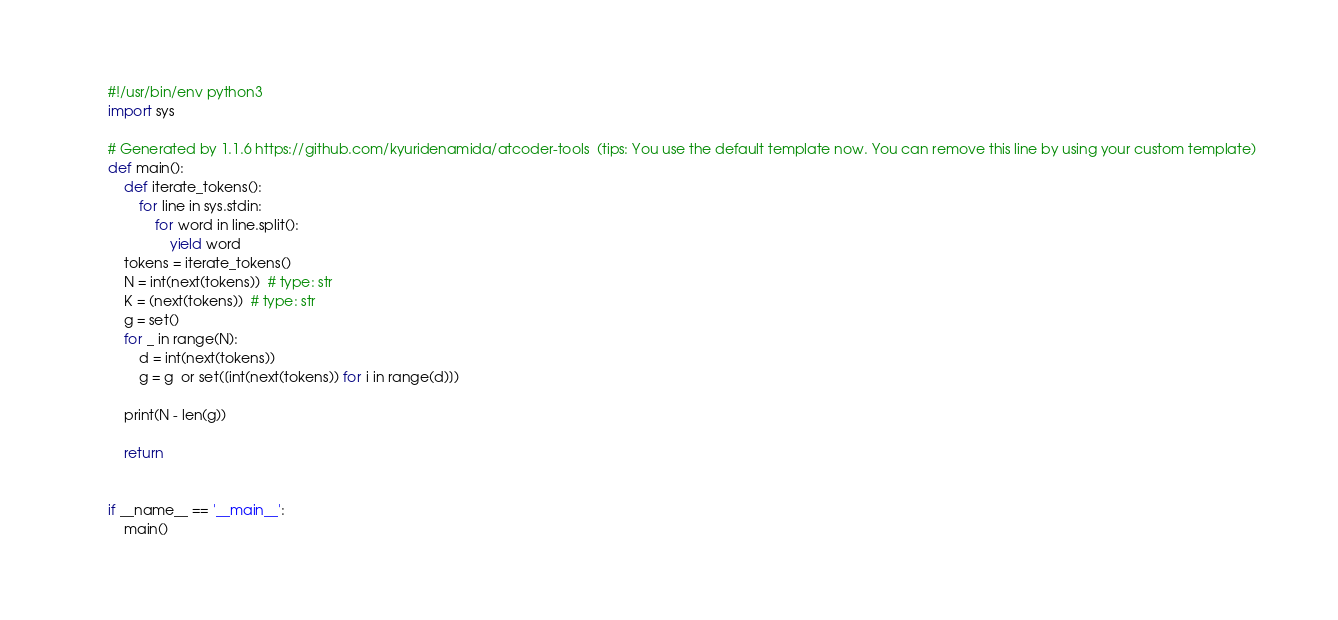<code> <loc_0><loc_0><loc_500><loc_500><_Python_>#!/usr/bin/env python3
import sys

# Generated by 1.1.6 https://github.com/kyuridenamida/atcoder-tools  (tips: You use the default template now. You can remove this line by using your custom template)
def main():
    def iterate_tokens():
        for line in sys.stdin:
            for word in line.split():
                yield word
    tokens = iterate_tokens()
    N = int(next(tokens))  # type: str
    K = (next(tokens))  # type: str
    g = set()
    for _ in range(N):
        d = int(next(tokens))
        g = g  or set([int(next(tokens)) for i in range(d)])

    print(N - len(g))    

    return


if __name__ == '__main__':
    main()
</code> 